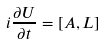Convert formula to latex. <formula><loc_0><loc_0><loc_500><loc_500>i \frac { \partial U } { \partial t } = [ A , L ]</formula> 